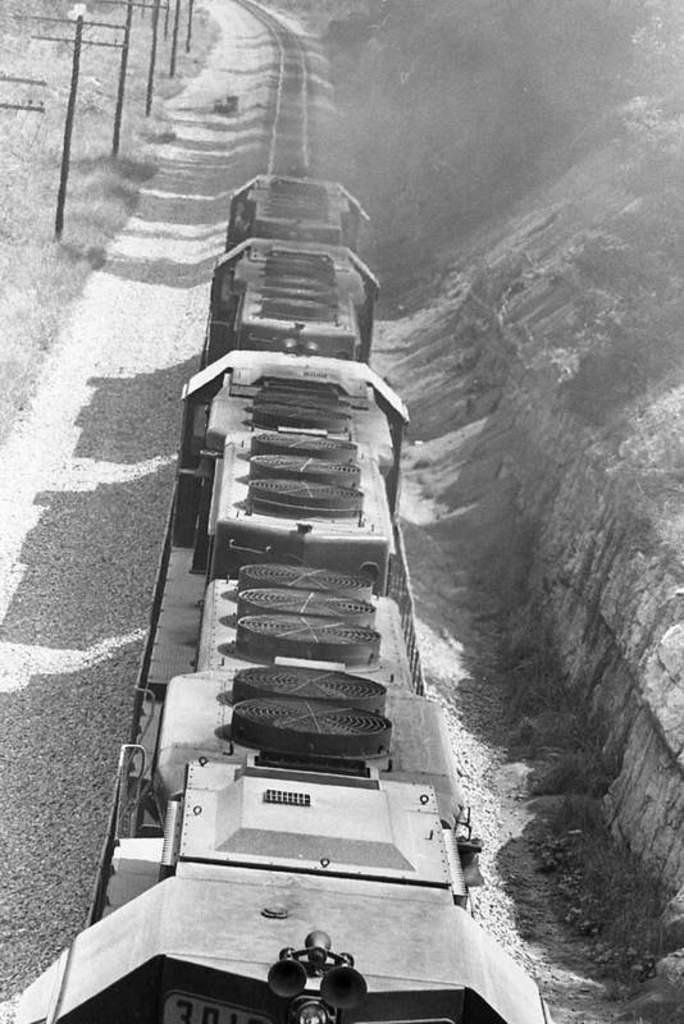What is the color scheme of the image? The image is black and white. What is the main subject in the image? There is a train in the middle of the image. What type of landscape surrounds the train? There is grassland on either side of the train. Can you see an umbrella being used by someone in the image? There is no umbrella present in the image. Are there any people in the image exchanging a kiss? There are no people visible in the image, so it is impossible to determine if they are exchanging a kiss. 